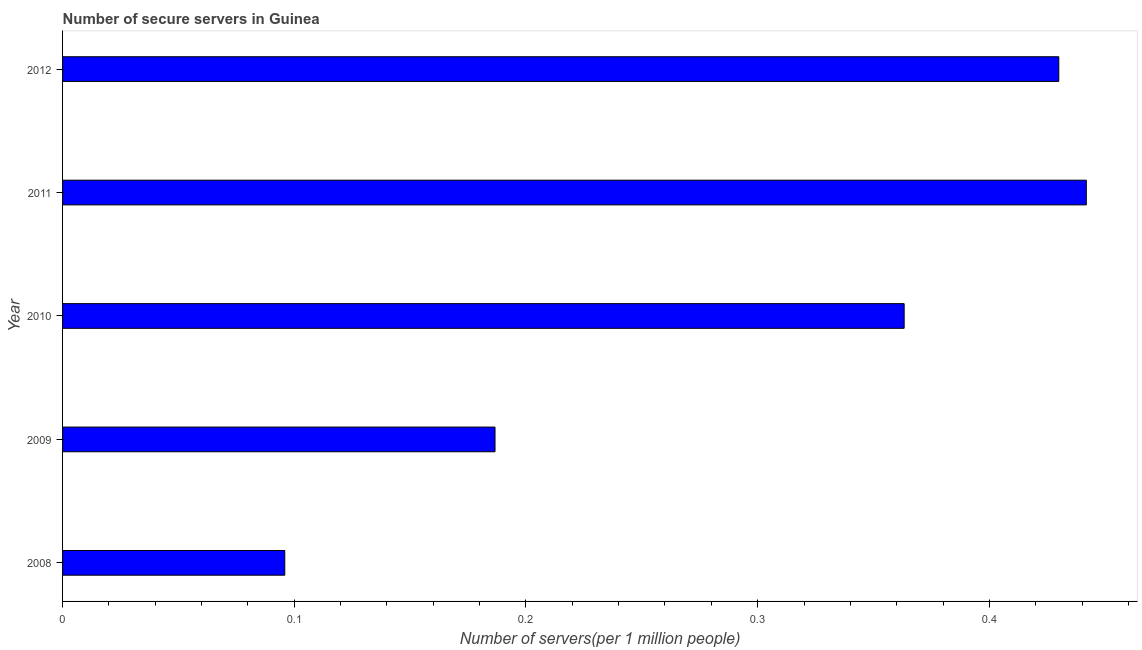Does the graph contain grids?
Your answer should be compact. No. What is the title of the graph?
Offer a terse response. Number of secure servers in Guinea. What is the label or title of the X-axis?
Your response must be concise. Number of servers(per 1 million people). What is the number of secure internet servers in 2009?
Provide a short and direct response. 0.19. Across all years, what is the maximum number of secure internet servers?
Give a very brief answer. 0.44. Across all years, what is the minimum number of secure internet servers?
Offer a terse response. 0.1. In which year was the number of secure internet servers minimum?
Provide a short and direct response. 2008. What is the sum of the number of secure internet servers?
Your response must be concise. 1.52. What is the difference between the number of secure internet servers in 2009 and 2010?
Provide a short and direct response. -0.18. What is the average number of secure internet servers per year?
Your answer should be compact. 0.3. What is the median number of secure internet servers?
Make the answer very short. 0.36. Do a majority of the years between 2008 and 2012 (inclusive) have number of secure internet servers greater than 0.08 ?
Your response must be concise. Yes. What is the ratio of the number of secure internet servers in 2009 to that in 2010?
Your answer should be very brief. 0.51. Is the difference between the number of secure internet servers in 2008 and 2012 greater than the difference between any two years?
Your answer should be very brief. No. What is the difference between the highest and the second highest number of secure internet servers?
Provide a short and direct response. 0.01. Is the sum of the number of secure internet servers in 2010 and 2011 greater than the maximum number of secure internet servers across all years?
Ensure brevity in your answer.  Yes. How many bars are there?
Your answer should be compact. 5. What is the difference between two consecutive major ticks on the X-axis?
Your answer should be compact. 0.1. What is the Number of servers(per 1 million people) in 2008?
Ensure brevity in your answer.  0.1. What is the Number of servers(per 1 million people) of 2009?
Make the answer very short. 0.19. What is the Number of servers(per 1 million people) in 2010?
Your answer should be compact. 0.36. What is the Number of servers(per 1 million people) of 2011?
Your answer should be very brief. 0.44. What is the Number of servers(per 1 million people) of 2012?
Offer a terse response. 0.43. What is the difference between the Number of servers(per 1 million people) in 2008 and 2009?
Give a very brief answer. -0.09. What is the difference between the Number of servers(per 1 million people) in 2008 and 2010?
Make the answer very short. -0.27. What is the difference between the Number of servers(per 1 million people) in 2008 and 2011?
Offer a very short reply. -0.35. What is the difference between the Number of servers(per 1 million people) in 2008 and 2012?
Offer a very short reply. -0.33. What is the difference between the Number of servers(per 1 million people) in 2009 and 2010?
Ensure brevity in your answer.  -0.18. What is the difference between the Number of servers(per 1 million people) in 2009 and 2011?
Keep it short and to the point. -0.26. What is the difference between the Number of servers(per 1 million people) in 2009 and 2012?
Offer a terse response. -0.24. What is the difference between the Number of servers(per 1 million people) in 2010 and 2011?
Provide a succinct answer. -0.08. What is the difference between the Number of servers(per 1 million people) in 2010 and 2012?
Provide a succinct answer. -0.07. What is the difference between the Number of servers(per 1 million people) in 2011 and 2012?
Provide a short and direct response. 0.01. What is the ratio of the Number of servers(per 1 million people) in 2008 to that in 2009?
Ensure brevity in your answer.  0.51. What is the ratio of the Number of servers(per 1 million people) in 2008 to that in 2010?
Offer a terse response. 0.26. What is the ratio of the Number of servers(per 1 million people) in 2008 to that in 2011?
Make the answer very short. 0.22. What is the ratio of the Number of servers(per 1 million people) in 2008 to that in 2012?
Keep it short and to the point. 0.22. What is the ratio of the Number of servers(per 1 million people) in 2009 to that in 2010?
Provide a succinct answer. 0.51. What is the ratio of the Number of servers(per 1 million people) in 2009 to that in 2011?
Provide a short and direct response. 0.42. What is the ratio of the Number of servers(per 1 million people) in 2009 to that in 2012?
Give a very brief answer. 0.43. What is the ratio of the Number of servers(per 1 million people) in 2010 to that in 2011?
Make the answer very short. 0.82. What is the ratio of the Number of servers(per 1 million people) in 2010 to that in 2012?
Offer a very short reply. 0.84. What is the ratio of the Number of servers(per 1 million people) in 2011 to that in 2012?
Your answer should be compact. 1.03. 